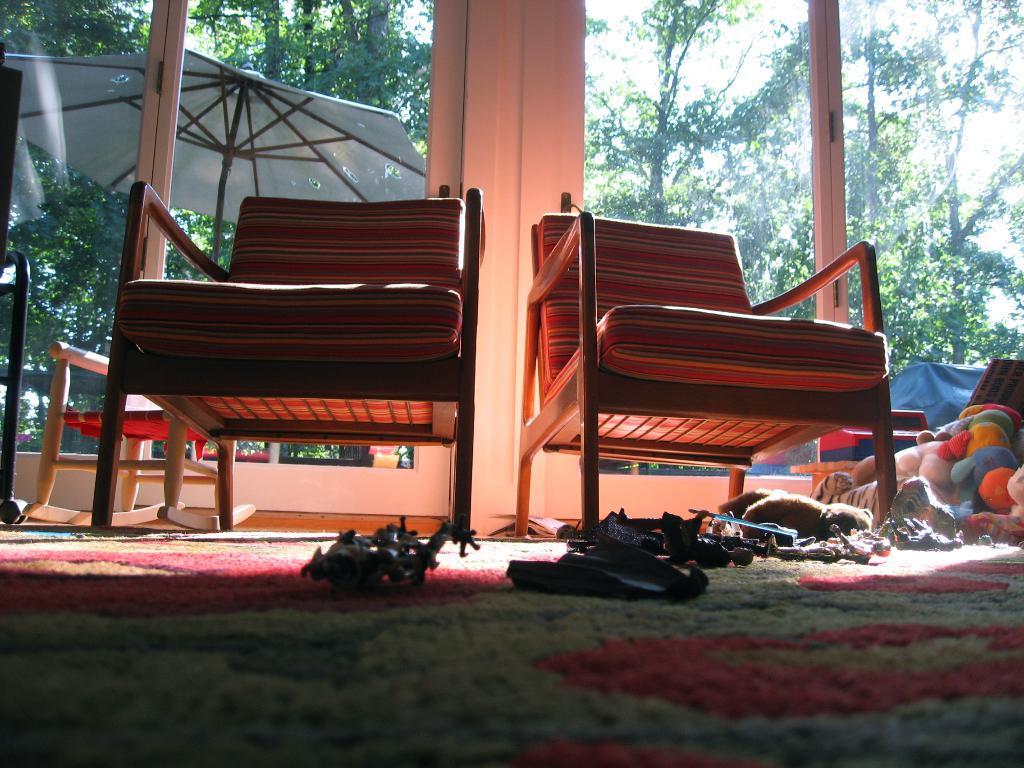Please provide a concise description of this image. In the center of the image we can see a chairs, some toys, dolls are present. At the top of the image we can see some trees, umbrella, sky, door are there. At the bottom of the image floor is present. 